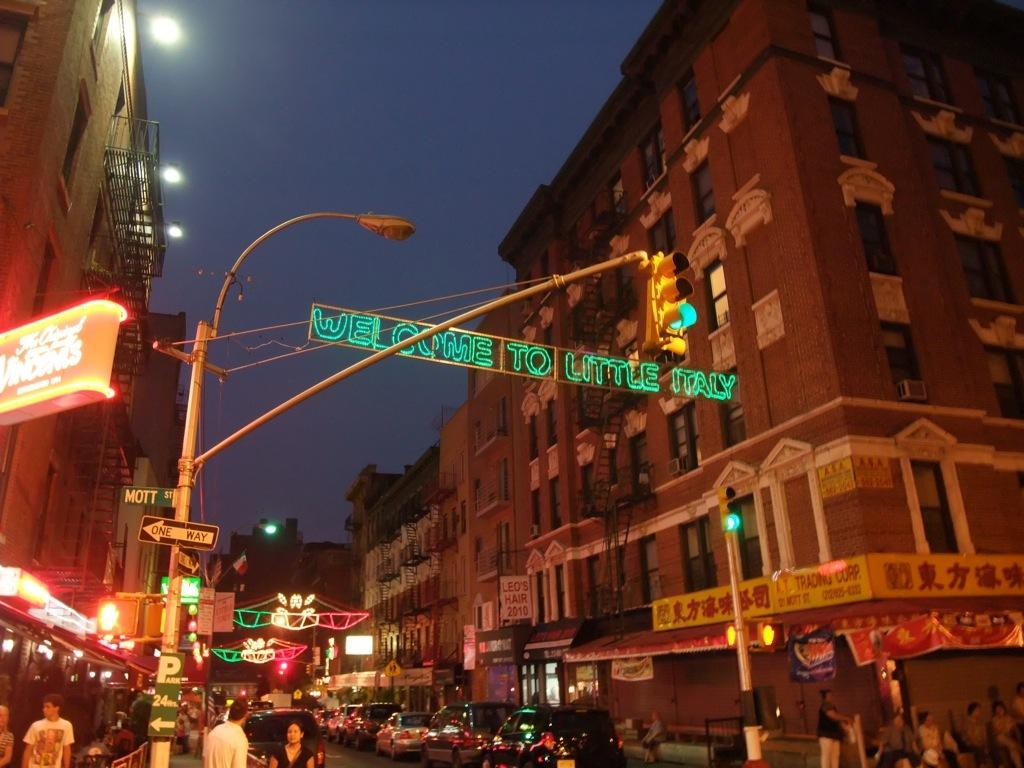What is happening in the image involving a group of people? There is a group of people standing in the image. What can be seen on the road in the image? There are vehicles on the road in the image. What is used to control traffic in the image? A traffic signal is present in the image. What is a tall structure supporting a light in the image? A light pole is visible in the image. What type of structures can be seen in the distance in the image? There are buildings in the background of the image. What color is the sky in the background of the image? The sky is blue in the background of the image. How many snakes are slipping on the rod in the image? There are no snakes or rods present in the image. What type of rod is being used by the people in the image? There is no rod being used by the people in the image. 